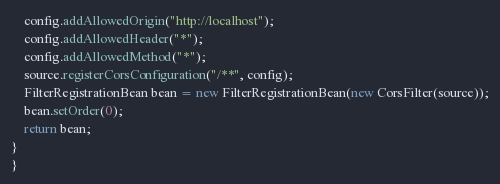Convert code to text. <code><loc_0><loc_0><loc_500><loc_500><_Java_>    config.addAllowedOrigin("http://localhost");
    config.addAllowedHeader("*");
    config.addAllowedMethod("*");
    source.registerCorsConfiguration("/**", config);
    FilterRegistrationBean bean = new FilterRegistrationBean(new CorsFilter(source));
    bean.setOrder(0);
    return bean;
}
}
</code> 